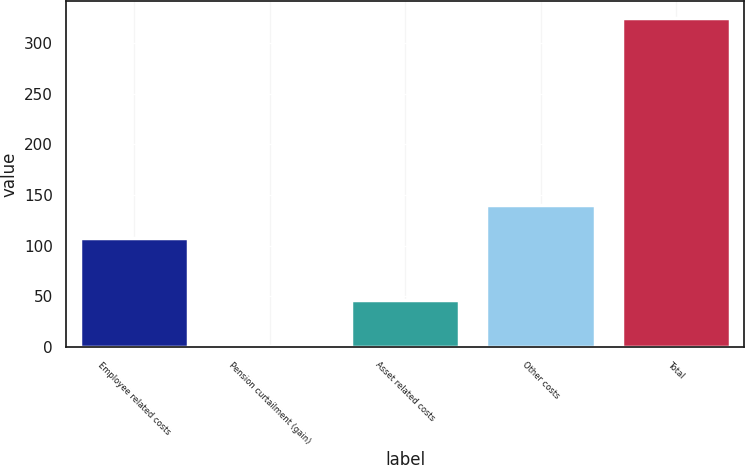Convert chart to OTSL. <chart><loc_0><loc_0><loc_500><loc_500><bar_chart><fcel>Employee related costs<fcel>Pension curtailment (gain)<fcel>Asset related costs<fcel>Other costs<fcel>Total<nl><fcel>108<fcel>1<fcel>46<fcel>140.4<fcel>325<nl></chart> 